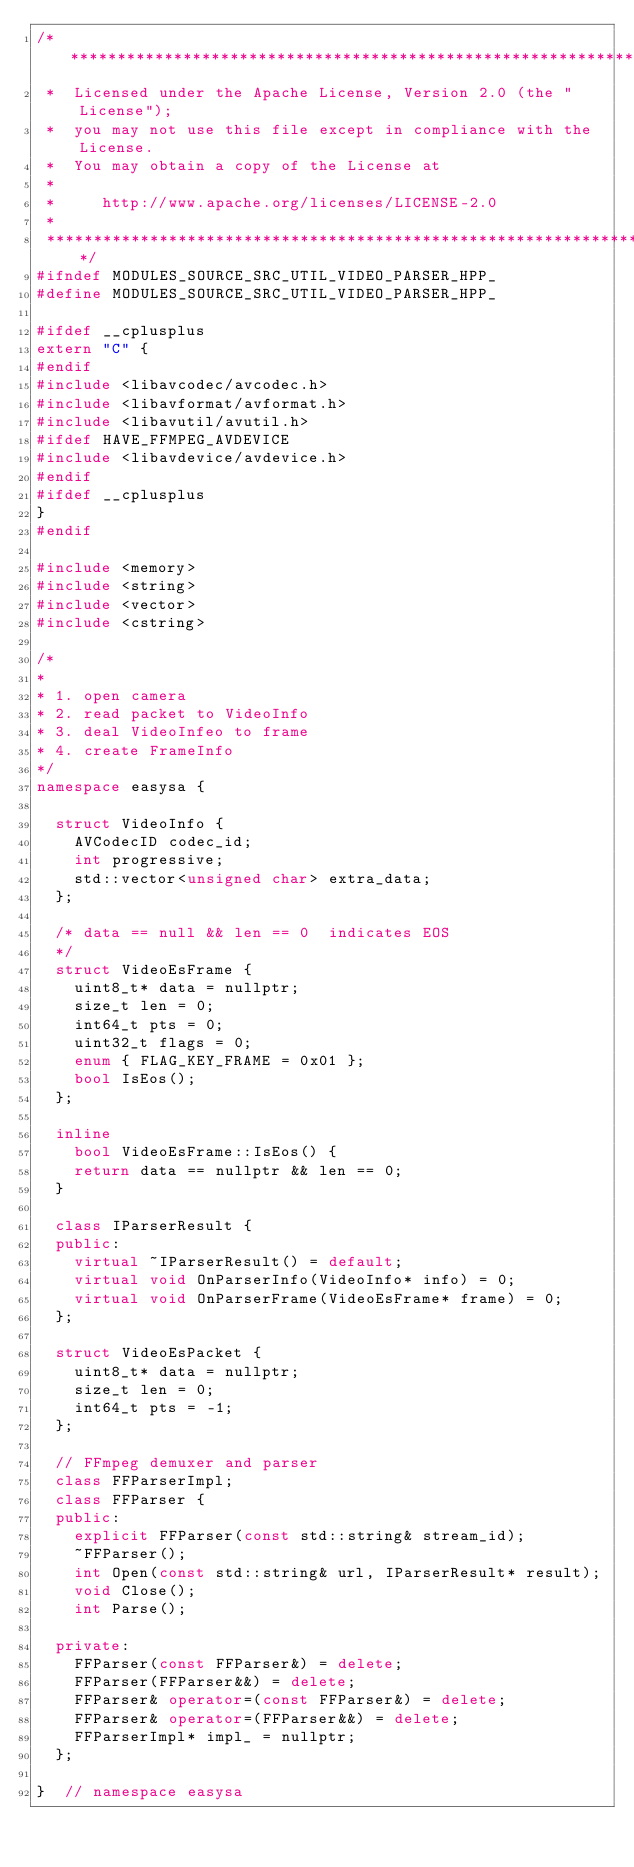<code> <loc_0><loc_0><loc_500><loc_500><_C++_>/*************************************************************************
 *  Licensed under the Apache License, Version 2.0 (the "License");
 *  you may not use this file except in compliance with the License.
 *  You may obtain a copy of the License at
 *
 *     http://www.apache.org/licenses/LICENSE-2.0
 *
 *************************************************************************/
#ifndef MODULES_SOURCE_SRC_UTIL_VIDEO_PARSER_HPP_
#define MODULES_SOURCE_SRC_UTIL_VIDEO_PARSER_HPP_

#ifdef __cplusplus
extern "C" {
#endif
#include <libavcodec/avcodec.h>
#include <libavformat/avformat.h>
#include <libavutil/avutil.h>
#ifdef HAVE_FFMPEG_AVDEVICE
#include <libavdevice/avdevice.h>
#endif
#ifdef __cplusplus
}
#endif

#include <memory>
#include <string>
#include <vector>
#include <cstring>

/*
*
* 1. open camera
* 2. read packet to VideoInfo
* 3. deal VideoInfeo to frame
* 4. create FrameInfo
*/
namespace easysa {

	struct VideoInfo {
		AVCodecID codec_id;
		int progressive;
		std::vector<unsigned char> extra_data;
	};

	/* data == null && len == 0  indicates EOS
	*/
	struct VideoEsFrame {
		uint8_t* data = nullptr;
		size_t len = 0;
		int64_t pts = 0;
		uint32_t flags = 0;
		enum { FLAG_KEY_FRAME = 0x01 };
		bool IsEos();
	};

	inline
		bool VideoEsFrame::IsEos() {
		return data == nullptr && len == 0;
	}

	class IParserResult {
	public:
		virtual ~IParserResult() = default;
		virtual void OnParserInfo(VideoInfo* info) = 0;
		virtual void OnParserFrame(VideoEsFrame* frame) = 0;
	};

	struct VideoEsPacket {
		uint8_t* data = nullptr;
		size_t len = 0;
		int64_t pts = -1;
	};

	// FFmpeg demuxer and parser
	class FFParserImpl;
	class FFParser {
	public:
		explicit FFParser(const std::string& stream_id);
		~FFParser();
		int Open(const std::string& url, IParserResult* result);
		void Close();
		int Parse();

	private:
		FFParser(const FFParser&) = delete;
		FFParser(FFParser&&) = delete;
		FFParser& operator=(const FFParser&) = delete;
		FFParser& operator=(FFParser&&) = delete;
		FFParserImpl* impl_ = nullptr;
	};

}  // namespace easysa</code> 